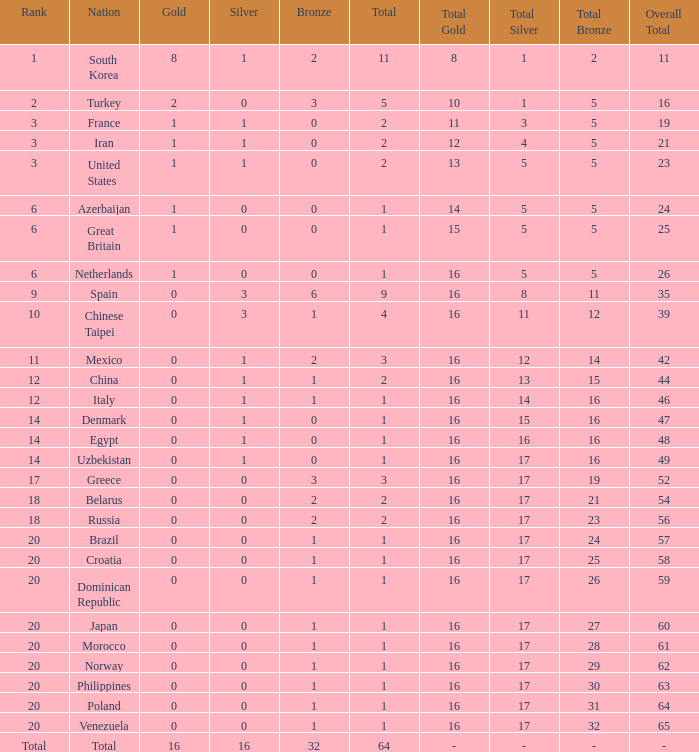What is the lowest number of gold medals the nation with less than 0 silver medals has? None. 